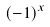<formula> <loc_0><loc_0><loc_500><loc_500>( - 1 ) ^ { x }</formula> 